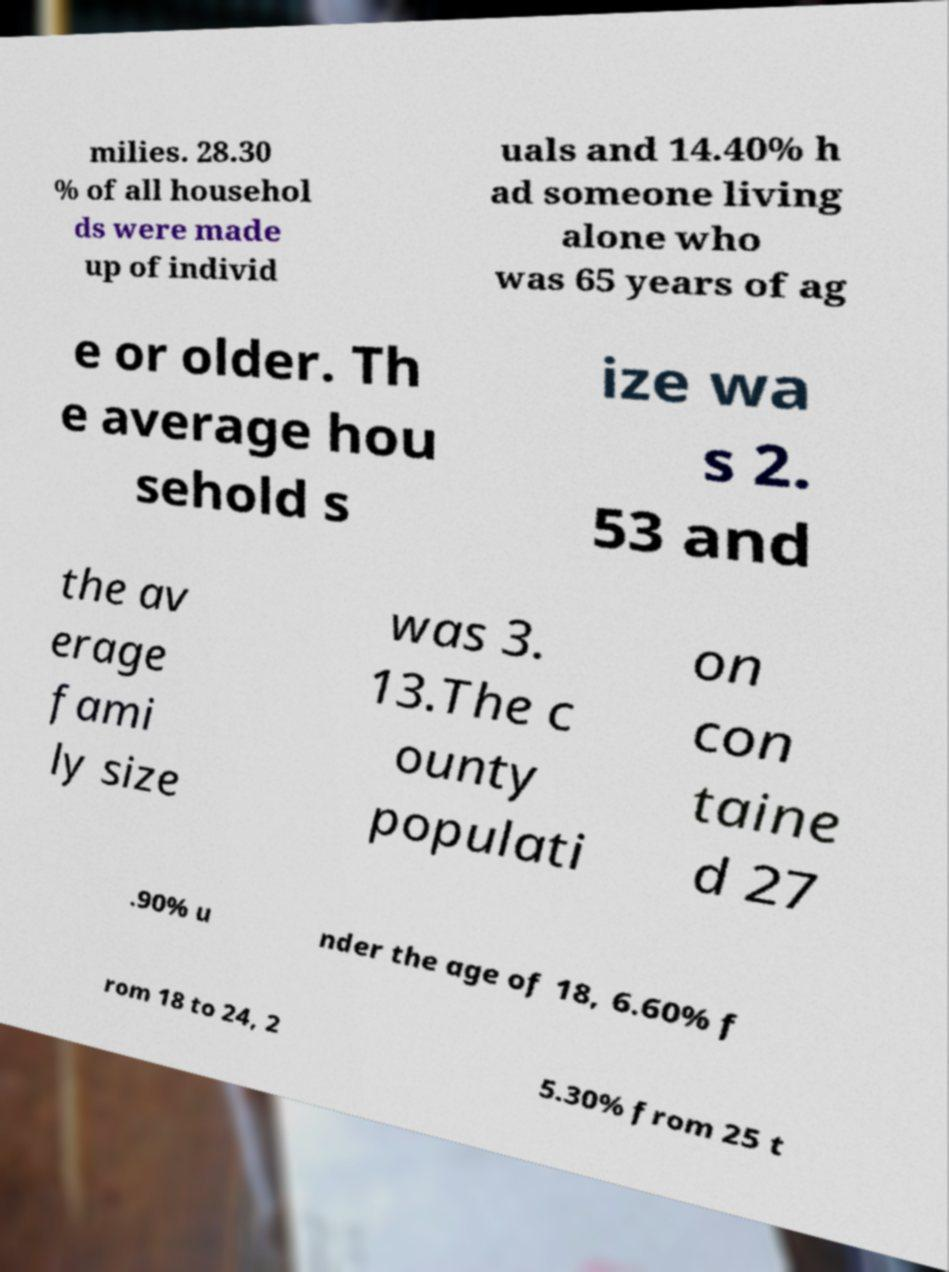For documentation purposes, I need the text within this image transcribed. Could you provide that? milies. 28.30 % of all househol ds were made up of individ uals and 14.40% h ad someone living alone who was 65 years of ag e or older. Th e average hou sehold s ize wa s 2. 53 and the av erage fami ly size was 3. 13.The c ounty populati on con taine d 27 .90% u nder the age of 18, 6.60% f rom 18 to 24, 2 5.30% from 25 t 